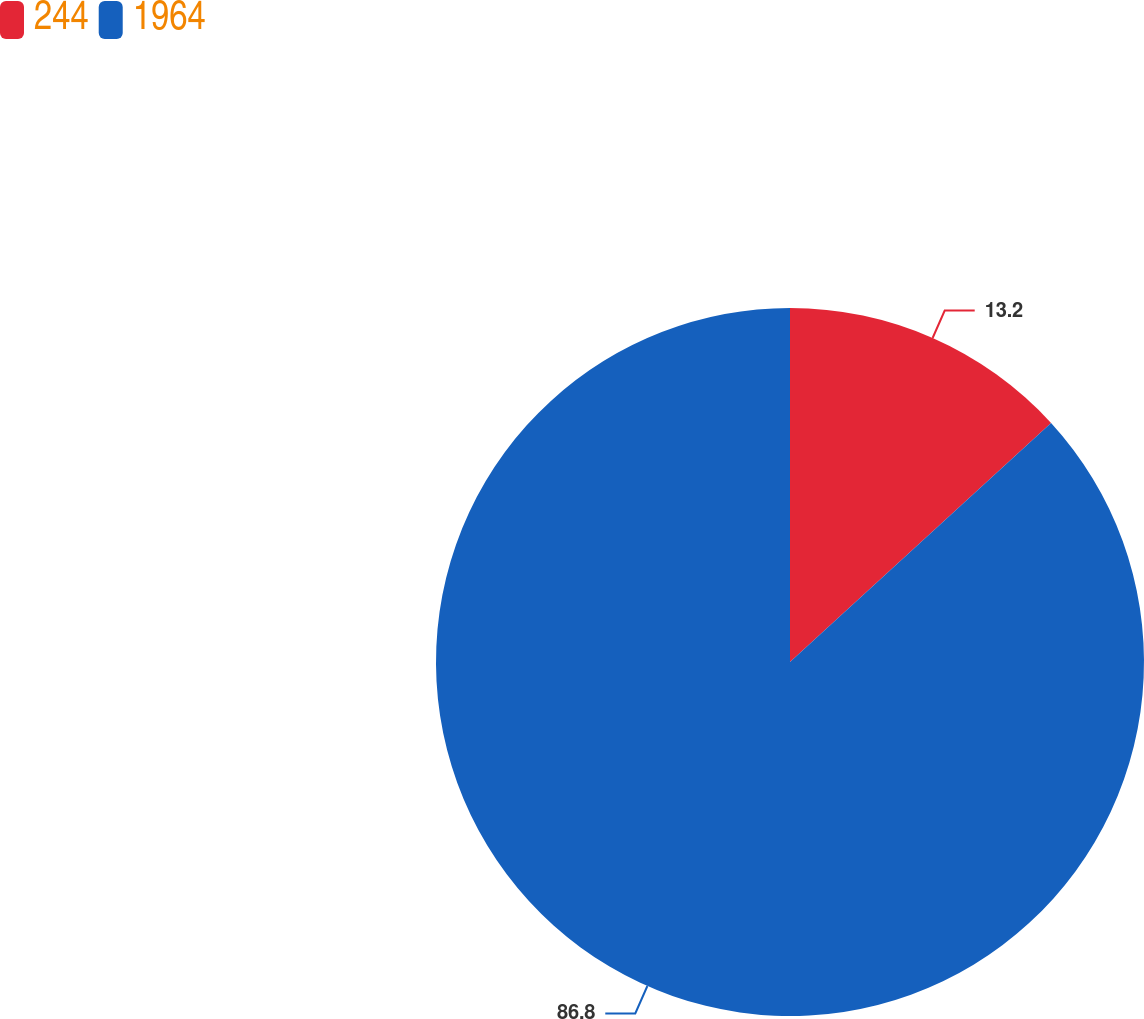<chart> <loc_0><loc_0><loc_500><loc_500><pie_chart><fcel>244<fcel>1964<nl><fcel>13.2%<fcel>86.8%<nl></chart> 